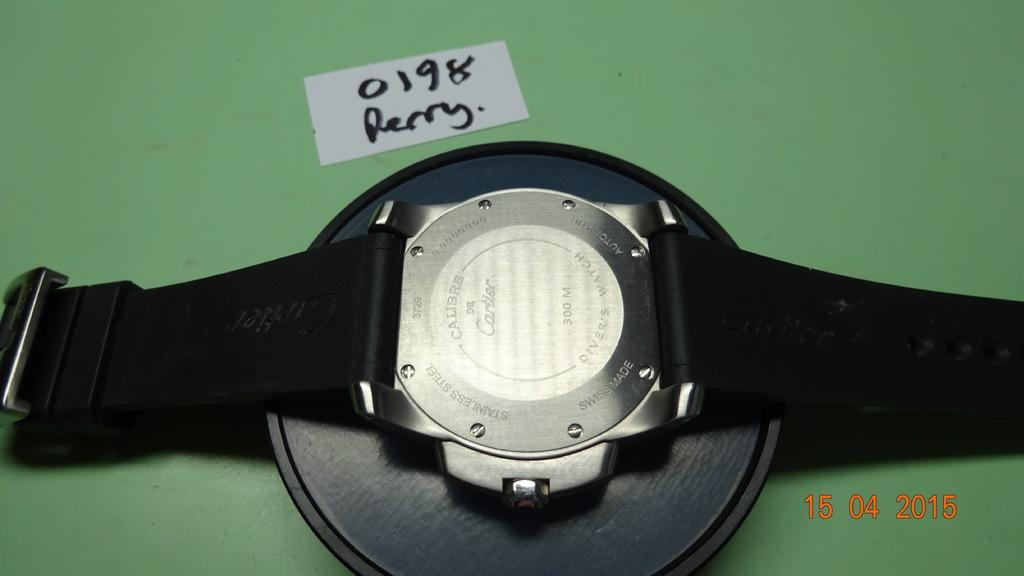<image>
Write a terse but informative summary of the picture. A white piece of paper says "0198 Perry." next to a watch. 